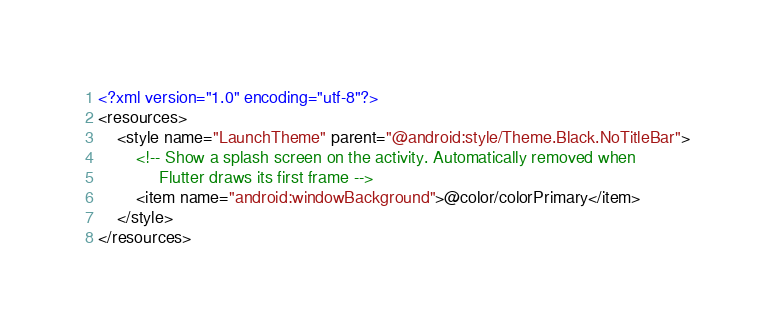<code> <loc_0><loc_0><loc_500><loc_500><_XML_><?xml version="1.0" encoding="utf-8"?>
<resources>
    <style name="LaunchTheme" parent="@android:style/Theme.Black.NoTitleBar">
        <!-- Show a splash screen on the activity. Automatically removed when
             Flutter draws its first frame -->
        <item name="android:windowBackground">@color/colorPrimary</item>
    </style>
</resources>
</code> 